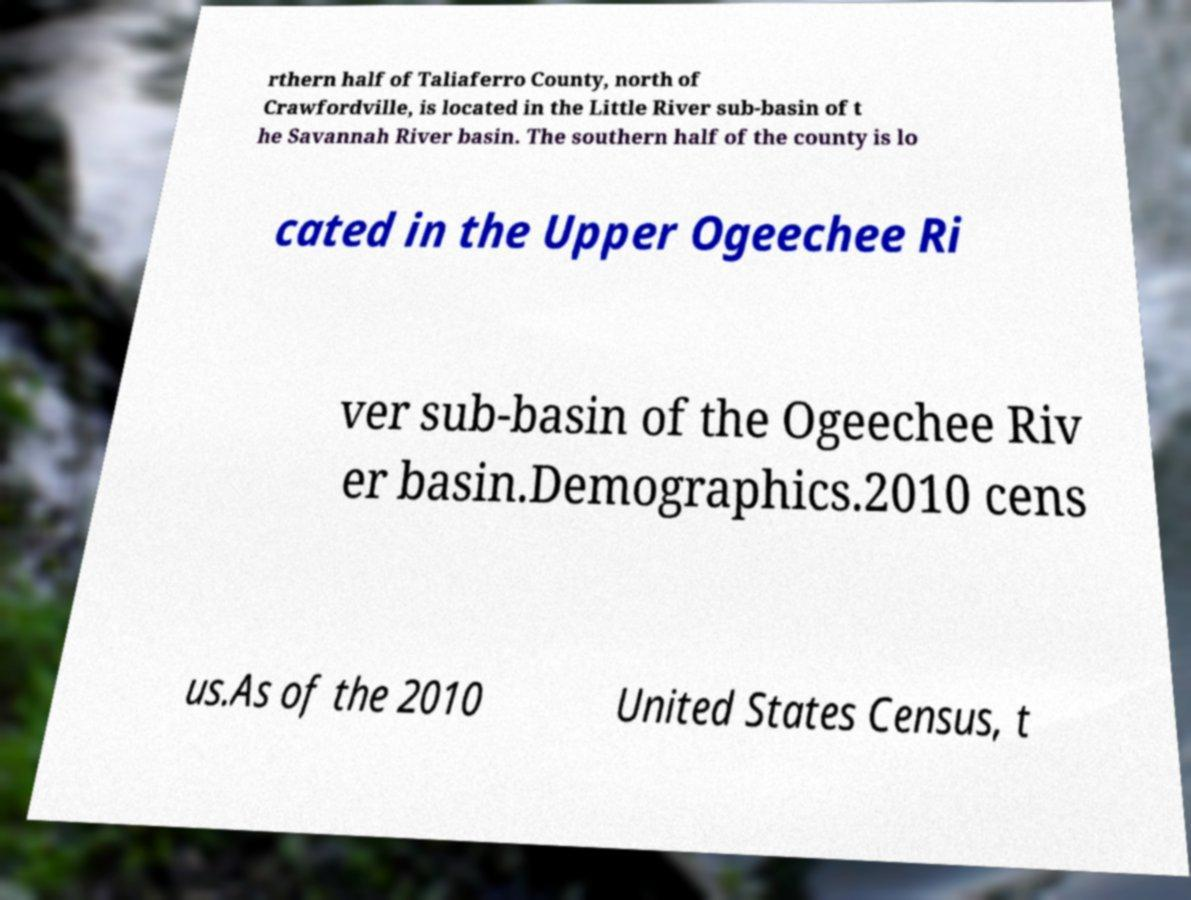I need the written content from this picture converted into text. Can you do that? rthern half of Taliaferro County, north of Crawfordville, is located in the Little River sub-basin of t he Savannah River basin. The southern half of the county is lo cated in the Upper Ogeechee Ri ver sub-basin of the Ogeechee Riv er basin.Demographics.2010 cens us.As of the 2010 United States Census, t 